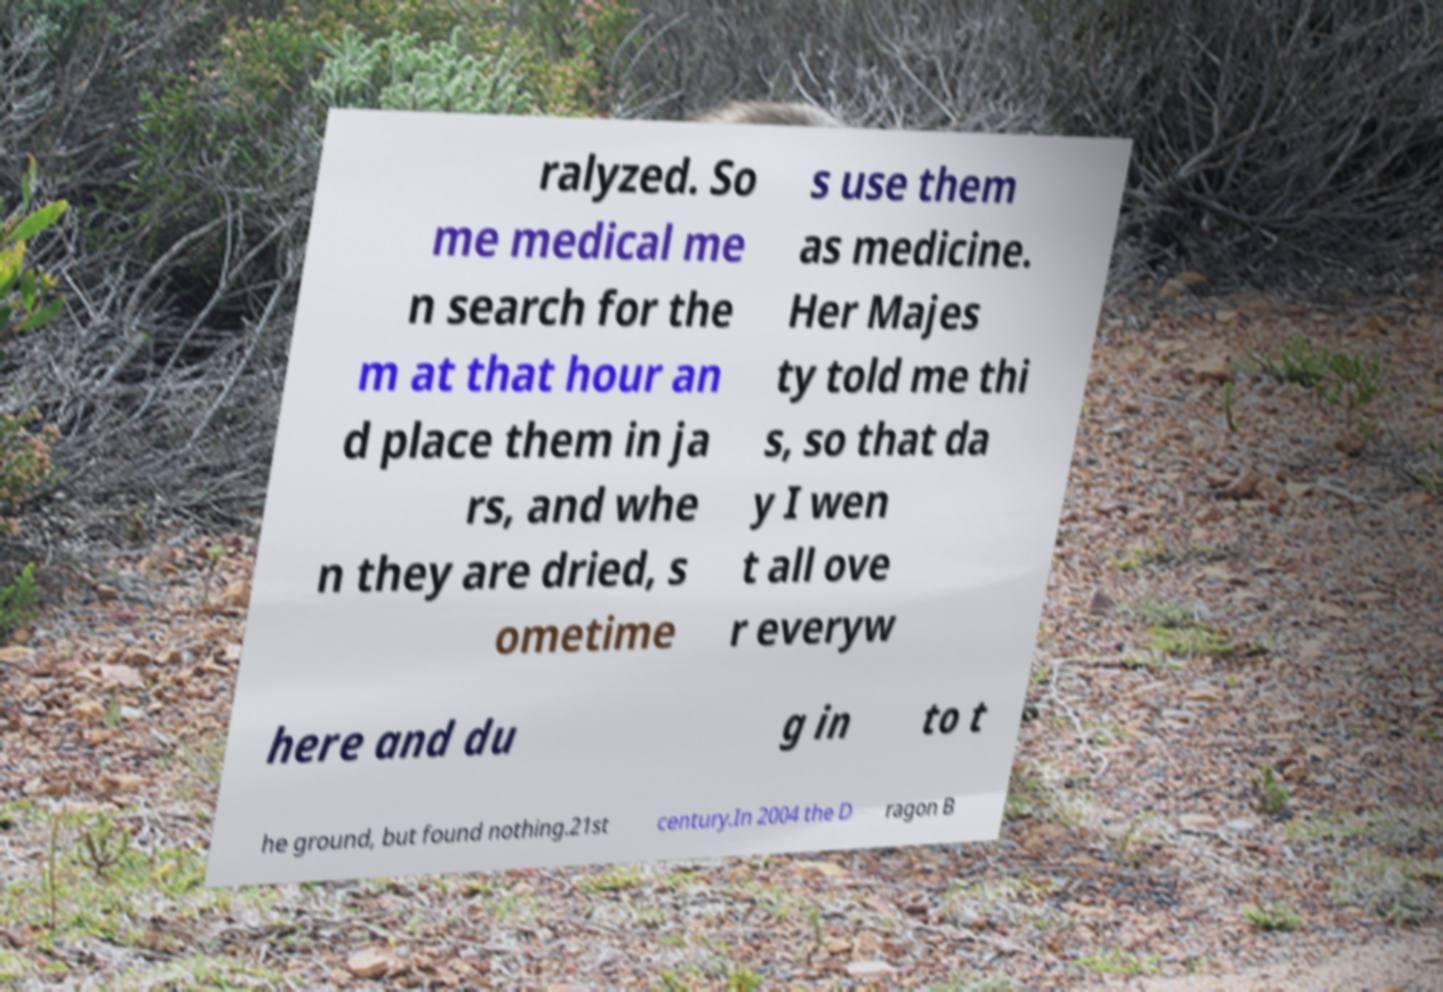I need the written content from this picture converted into text. Can you do that? ralyzed. So me medical me n search for the m at that hour an d place them in ja rs, and whe n they are dried, s ometime s use them as medicine. Her Majes ty told me thi s, so that da y I wen t all ove r everyw here and du g in to t he ground, but found nothing.21st century.In 2004 the D ragon B 